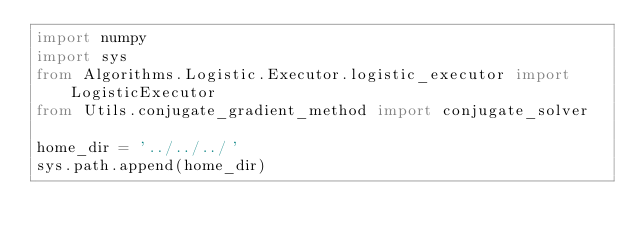Convert code to text. <code><loc_0><loc_0><loc_500><loc_500><_Python_>import numpy
import sys
from Algorithms.Logistic.Executor.logistic_executor import LogisticExecutor
from Utils.conjugate_gradient_method import conjugate_solver

home_dir = '../../../'
sys.path.append(home_dir)
</code> 